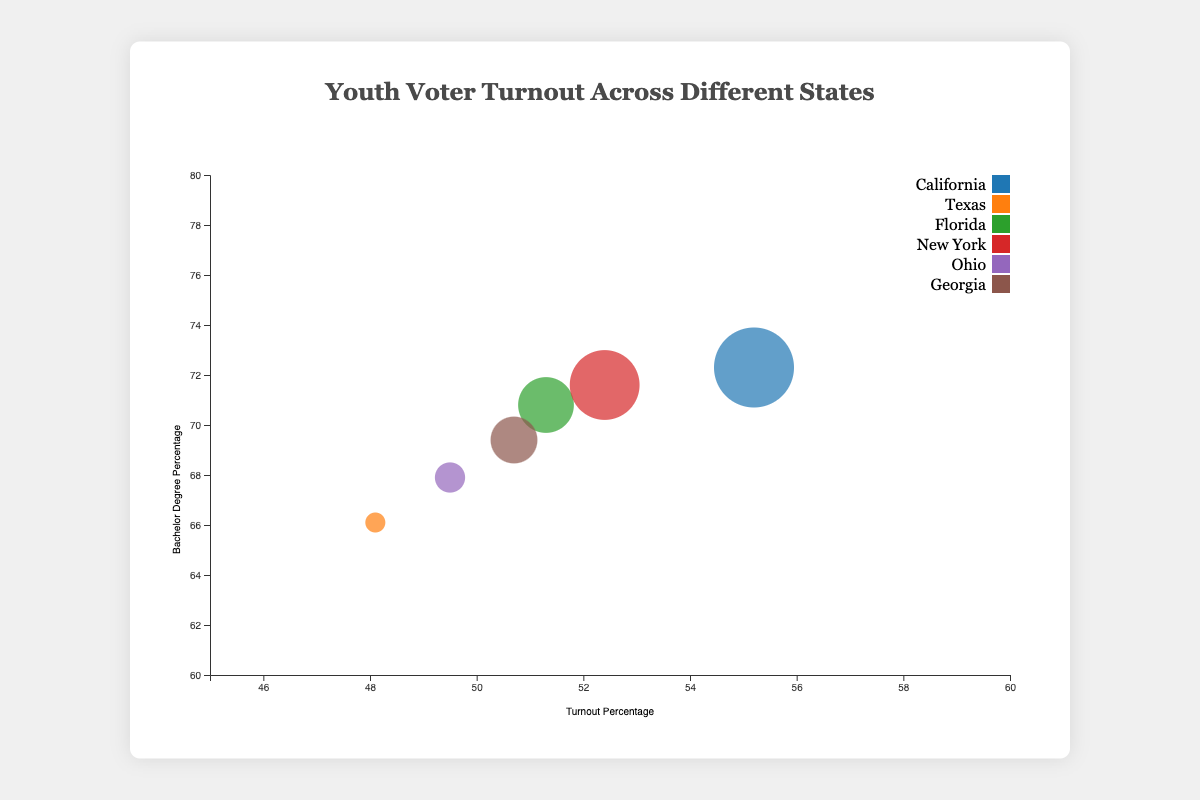What state has the highest youth voter turnout percentage? Look for the circle that is placed furthest to the right on the x-axis, which represents turnout percentage. The state with the highest youth voter turnout percentage is California with 55.2%.
Answer: California Which state has the smallest size bubble? The size of the bubble is determined by the percentage of youth with some college education. The smallest bubble represents Texas, which has 64.2% of youth with some college education.
Answer: Texas What's the title of the chart? The title is usually positioned at the top center of the chart. The title of the chart is "Youth Voter Turnout Across Different States."
Answer: Youth Voter Turnout Across Different States How many states are represented in this chart? Each unique color represents a different state. By counting the number of unique colors or legend items, we can determine that there are 6 states represented.
Answer: 6 Which state has the highest percentage of youth with a bachelor's degree? Look for the circle positioned highest on the y-axis, which represents the percentage with a bachelor's degree. The state with the highest percentage is California, with 72.3%.
Answer: California Which state has the lowest youth voter turnout percentage? Look for the circle that is positioned furthest to the left on the x-axis. The state with the lowest youth voter turnout percentage is Texas with 48.1%.
Answer: Texas In California, what's the difference between the percentage of youth with a high school diploma and those with some college? For California, subtract the percentage of youth with some college (68.9%) from the percentage with a high school diploma (78.4%). The difference is 78.4% - 68.9% = 9.5%.
Answer: 9.5% Compare the youth voter turnout percentages of Florida and New York. Which state has a higher percentage? Look at the x-axis positions for both Florida and New York circles. New York has a turnout percentage of 52.4%, which is higher than Florida's 51.3%.
Answer: New York Which state has a bubble size closest to the middle of the size range? Bubbles' sizes correspond to the percentage of youth with some college. The middle value (the median) would represent around 66.5% (average of the range from 64.2% to 68.9%). Ohio, with 65.0%, is closest to this value.
Answer: Ohio What is the color used for the New York bubble? Check the color legend associated with New York. The color assigned is a categorical value from the d3.schemeCategory10 color palette. New York is represented by a specific color in this palette (e.g., blue or orange).
Answer: (specific color from palette) 